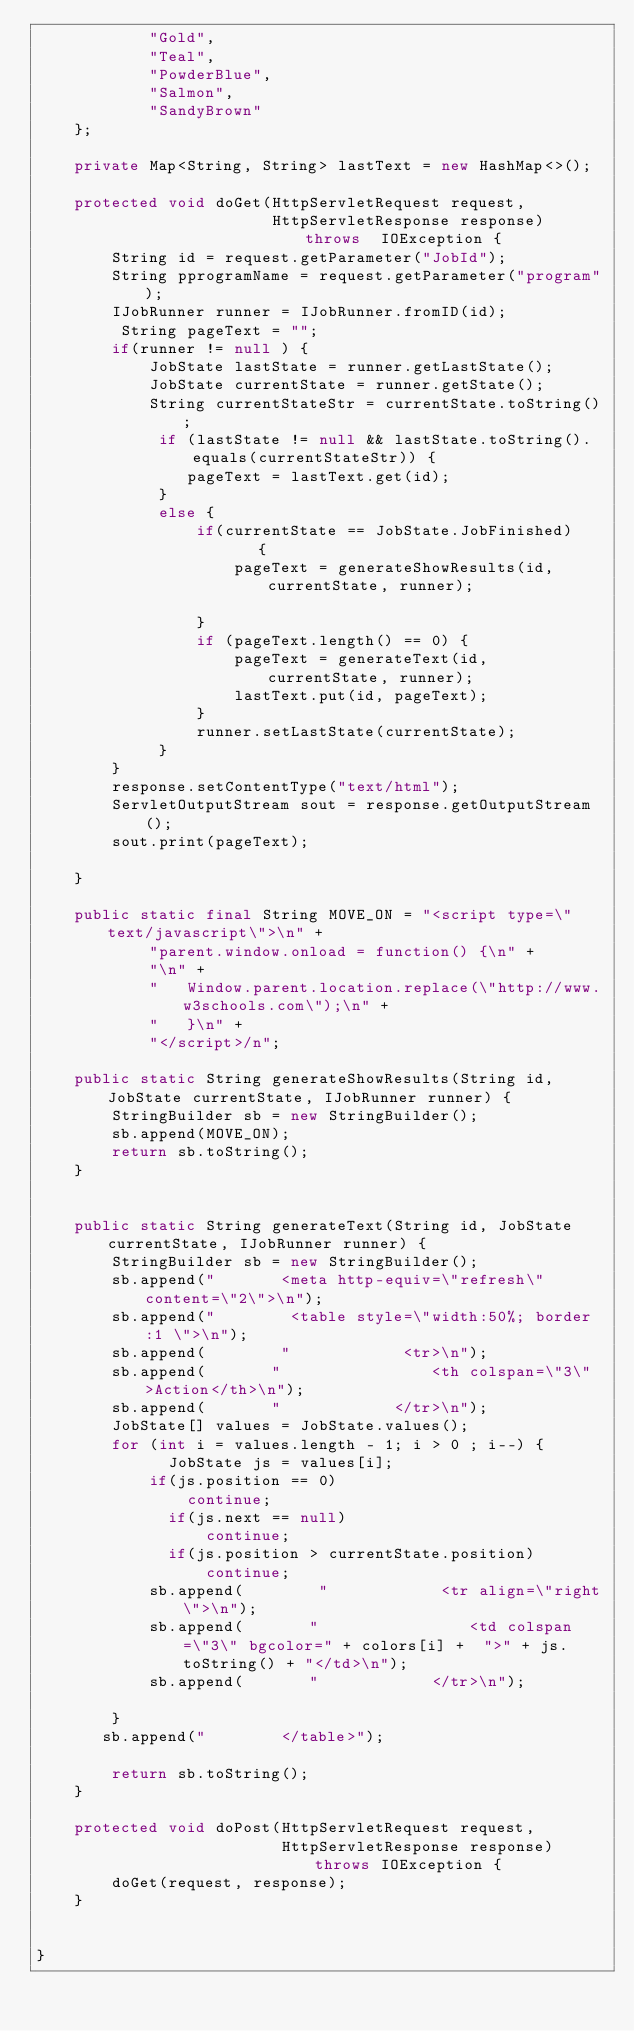Convert code to text. <code><loc_0><loc_0><loc_500><loc_500><_Java_>            "Gold",
            "Teal",
            "PowderBlue",
            "Salmon",
            "SandyBrown"
    };

    private Map<String, String> lastText = new HashMap<>();

    protected void doGet(HttpServletRequest request,
                         HttpServletResponse response) throws  IOException {
        String id = request.getParameter("JobId");
        String pprogramName = request.getParameter("program");
        IJobRunner runner = IJobRunner.fromID(id);
         String pageText = "";
        if(runner != null ) {
            JobState lastState = runner.getLastState();
            JobState currentState = runner.getState();
            String currentStateStr = currentState.toString();
             if (lastState != null && lastState.toString().equals(currentStateStr)) {
                pageText = lastText.get(id);
             }
             else {
                 if(currentState == JobState.JobFinished)    {
                     pageText = generateShowResults(id, currentState, runner);

                 }
                 if (pageText.length() == 0) {
                     pageText = generateText(id, currentState, runner);
                     lastText.put(id, pageText);
                 }
                 runner.setLastState(currentState);
             }
        }
        response.setContentType("text/html");
        ServletOutputStream sout = response.getOutputStream();
        sout.print(pageText);

    }

    public static final String MOVE_ON = "<script type=\"text/javascript\">\n" +
            "parent.window.onload = function() {\n" +
            "\n" +
            "   Window.parent.location.replace(\"http://www.w3schools.com\");\n" +
            "   }\n" +
            "</script>/n";

    public static String generateShowResults(String id, JobState currentState, IJobRunner runner) {
        StringBuilder sb = new StringBuilder();
        sb.append(MOVE_ON);
        return sb.toString();
    }


    public static String generateText(String id, JobState currentState, IJobRunner runner) {
        StringBuilder sb = new StringBuilder();
        sb.append("       <meta http-equiv=\"refresh\" content=\"2\">\n");
        sb.append("        <table style=\"width:50%; border:1 \">\n");
        sb.append(        "            <tr>\n");
        sb.append(       "                <th colspan=\"3\" >Action</th>\n");
        sb.append(       "            </tr>\n");
        JobState[] values = JobState.values();
        for (int i = values.length - 1; i > 0 ; i--) {
              JobState js = values[i];
            if(js.position == 0)
                continue;
              if(js.next == null)
                  continue;
              if(js.position > currentState.position)
                  continue;
            sb.append(        "            <tr align=\"right\">\n");
            sb.append(       "                <td colspan=\"3\" bgcolor=" + colors[i] +  ">" + js.toString() + "</td>\n");
            sb.append(       "            </tr>\n");

        }
       sb.append("        </table>");

        return sb.toString();
    }

    protected void doPost(HttpServletRequest request,
                          HttpServletResponse response) throws IOException {
        doGet(request, response);
    }


}
</code> 